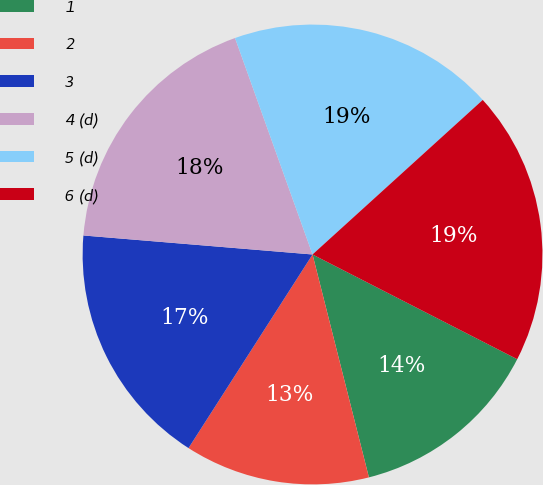<chart> <loc_0><loc_0><loc_500><loc_500><pie_chart><fcel>1<fcel>2<fcel>3<fcel>4 (d)<fcel>5 (d)<fcel>6 (d)<nl><fcel>13.53%<fcel>13.01%<fcel>17.25%<fcel>18.21%<fcel>18.74%<fcel>19.26%<nl></chart> 